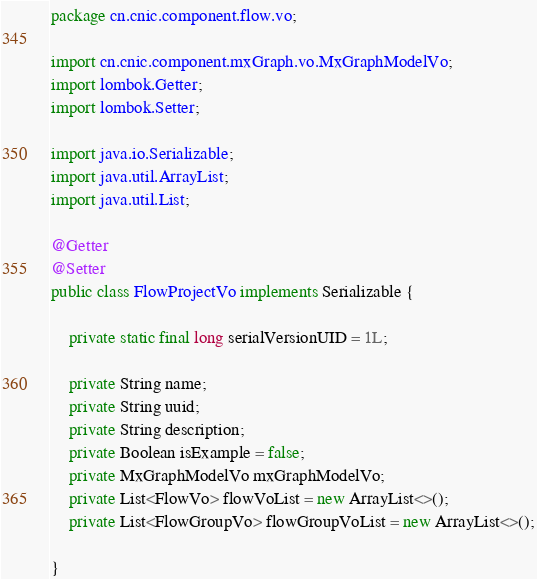Convert code to text. <code><loc_0><loc_0><loc_500><loc_500><_Java_>package cn.cnic.component.flow.vo;

import cn.cnic.component.mxGraph.vo.MxGraphModelVo;
import lombok.Getter;
import lombok.Setter;

import java.io.Serializable;
import java.util.ArrayList;
import java.util.List;

@Getter
@Setter
public class FlowProjectVo implements Serializable {

    private static final long serialVersionUID = 1L;

    private String name;
    private String uuid;
    private String description;
    private Boolean isExample = false;
    private MxGraphModelVo mxGraphModelVo;
    private List<FlowVo> flowVoList = new ArrayList<>();
    private List<FlowGroupVo> flowGroupVoList = new ArrayList<>();

}
</code> 